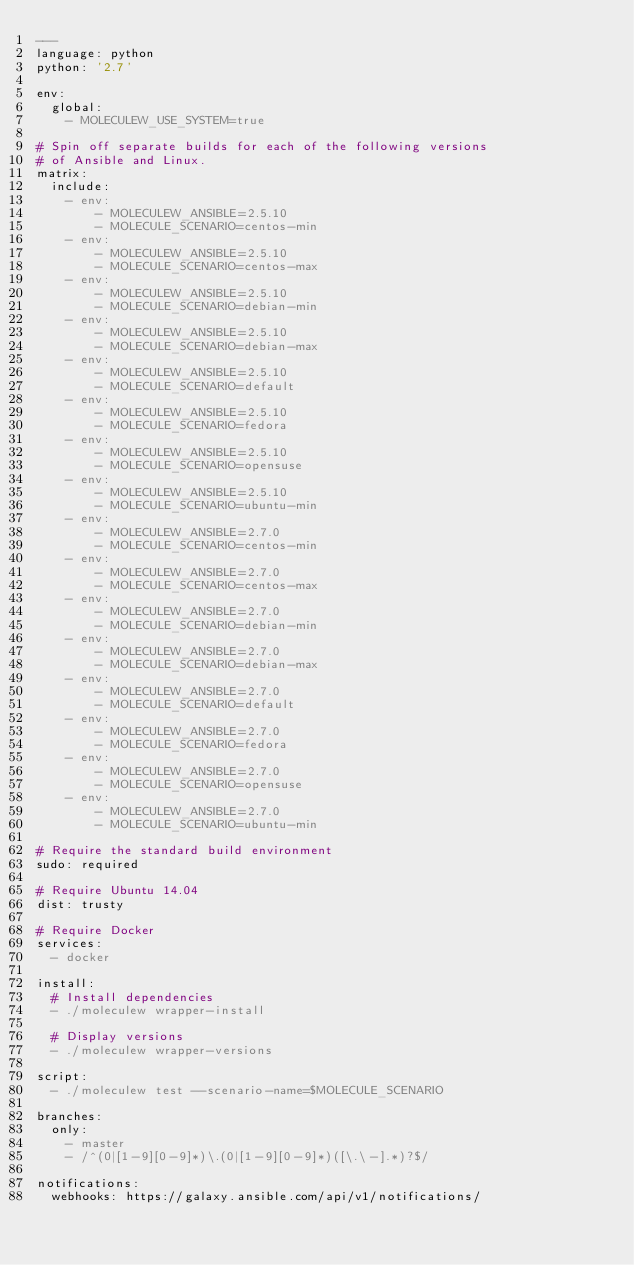<code> <loc_0><loc_0><loc_500><loc_500><_YAML_>---
language: python
python: '2.7'

env:
  global:
    - MOLECULEW_USE_SYSTEM=true

# Spin off separate builds for each of the following versions
# of Ansible and Linux.
matrix:
  include:
    - env:
        - MOLECULEW_ANSIBLE=2.5.10
        - MOLECULE_SCENARIO=centos-min
    - env:
        - MOLECULEW_ANSIBLE=2.5.10
        - MOLECULE_SCENARIO=centos-max
    - env:
        - MOLECULEW_ANSIBLE=2.5.10
        - MOLECULE_SCENARIO=debian-min
    - env:
        - MOLECULEW_ANSIBLE=2.5.10
        - MOLECULE_SCENARIO=debian-max
    - env:
        - MOLECULEW_ANSIBLE=2.5.10
        - MOLECULE_SCENARIO=default
    - env:
        - MOLECULEW_ANSIBLE=2.5.10
        - MOLECULE_SCENARIO=fedora
    - env:
        - MOLECULEW_ANSIBLE=2.5.10
        - MOLECULE_SCENARIO=opensuse
    - env:
        - MOLECULEW_ANSIBLE=2.5.10
        - MOLECULE_SCENARIO=ubuntu-min
    - env:
        - MOLECULEW_ANSIBLE=2.7.0
        - MOLECULE_SCENARIO=centos-min
    - env:
        - MOLECULEW_ANSIBLE=2.7.0
        - MOLECULE_SCENARIO=centos-max
    - env:
        - MOLECULEW_ANSIBLE=2.7.0
        - MOLECULE_SCENARIO=debian-min
    - env:
        - MOLECULEW_ANSIBLE=2.7.0
        - MOLECULE_SCENARIO=debian-max
    - env:
        - MOLECULEW_ANSIBLE=2.7.0
        - MOLECULE_SCENARIO=default
    - env:
        - MOLECULEW_ANSIBLE=2.7.0
        - MOLECULE_SCENARIO=fedora
    - env:
        - MOLECULEW_ANSIBLE=2.7.0
        - MOLECULE_SCENARIO=opensuse
    - env:
        - MOLECULEW_ANSIBLE=2.7.0
        - MOLECULE_SCENARIO=ubuntu-min

# Require the standard build environment
sudo: required

# Require Ubuntu 14.04
dist: trusty

# Require Docker
services:
  - docker

install:
  # Install dependencies
  - ./moleculew wrapper-install

  # Display versions
  - ./moleculew wrapper-versions

script:
  - ./moleculew test --scenario-name=$MOLECULE_SCENARIO

branches:
  only:
    - master
    - /^(0|[1-9][0-9]*)\.(0|[1-9][0-9]*)([\.\-].*)?$/

notifications:
  webhooks: https://galaxy.ansible.com/api/v1/notifications/
</code> 